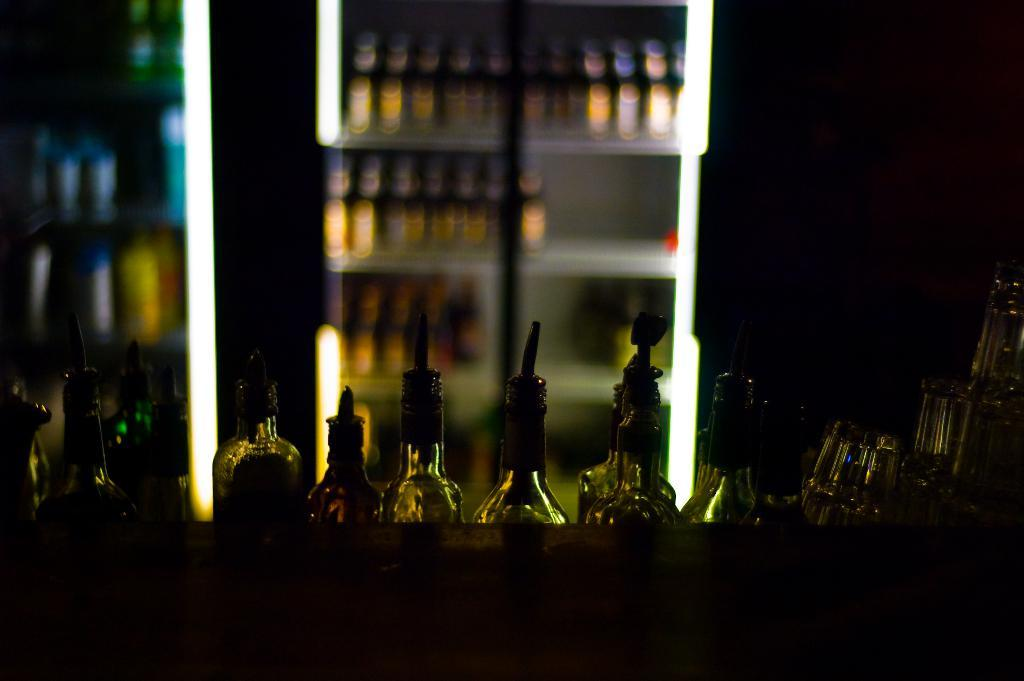What objects can be seen in the image? There are bottles in the image. What type of beast can be seen interacting with the bottles in the image? There is no beast present in the image; it only features bottles. Are there any beads visible in the image? There is no mention of beads in the provided facts, and therefore we cannot determine their presence in the image. 